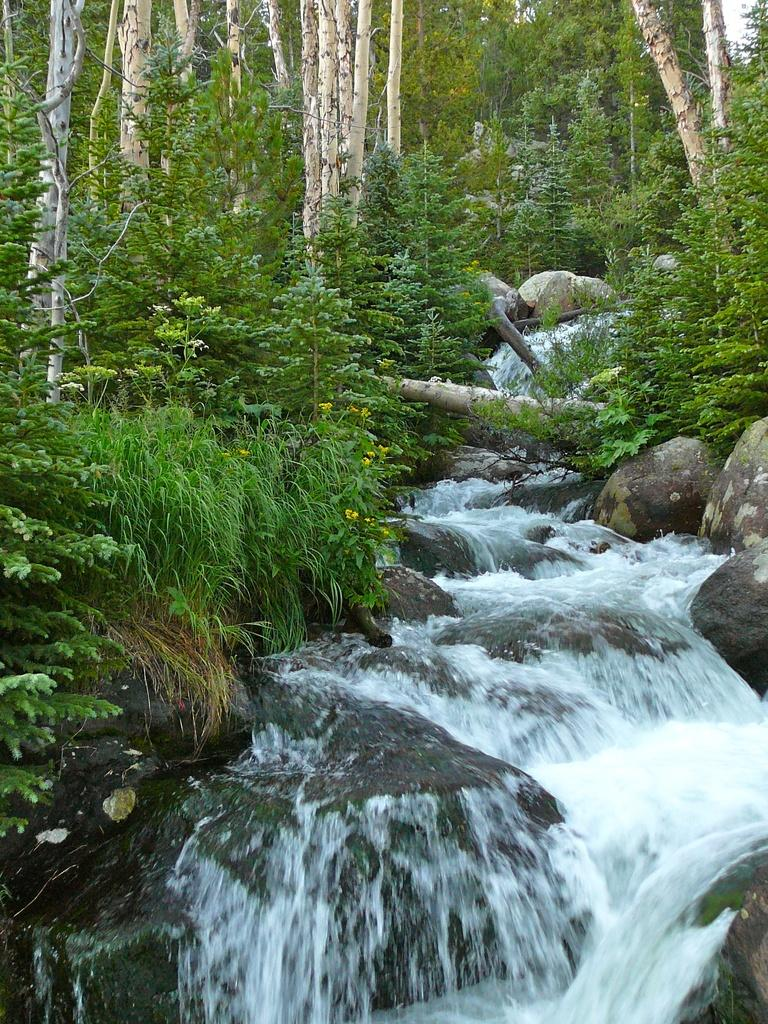What natural feature is the main subject of the image? There is a waterfall in the image. What type of vegetation is on the left side of the image? There are plants on the left side of the image. What can be seen in the background of the image? There are trees visible in the background of the image. Can you tell me how many friends are standing near the waterfall in the image? There is no mention of friends or any people in the image; it only features a waterfall, plants, and trees. 